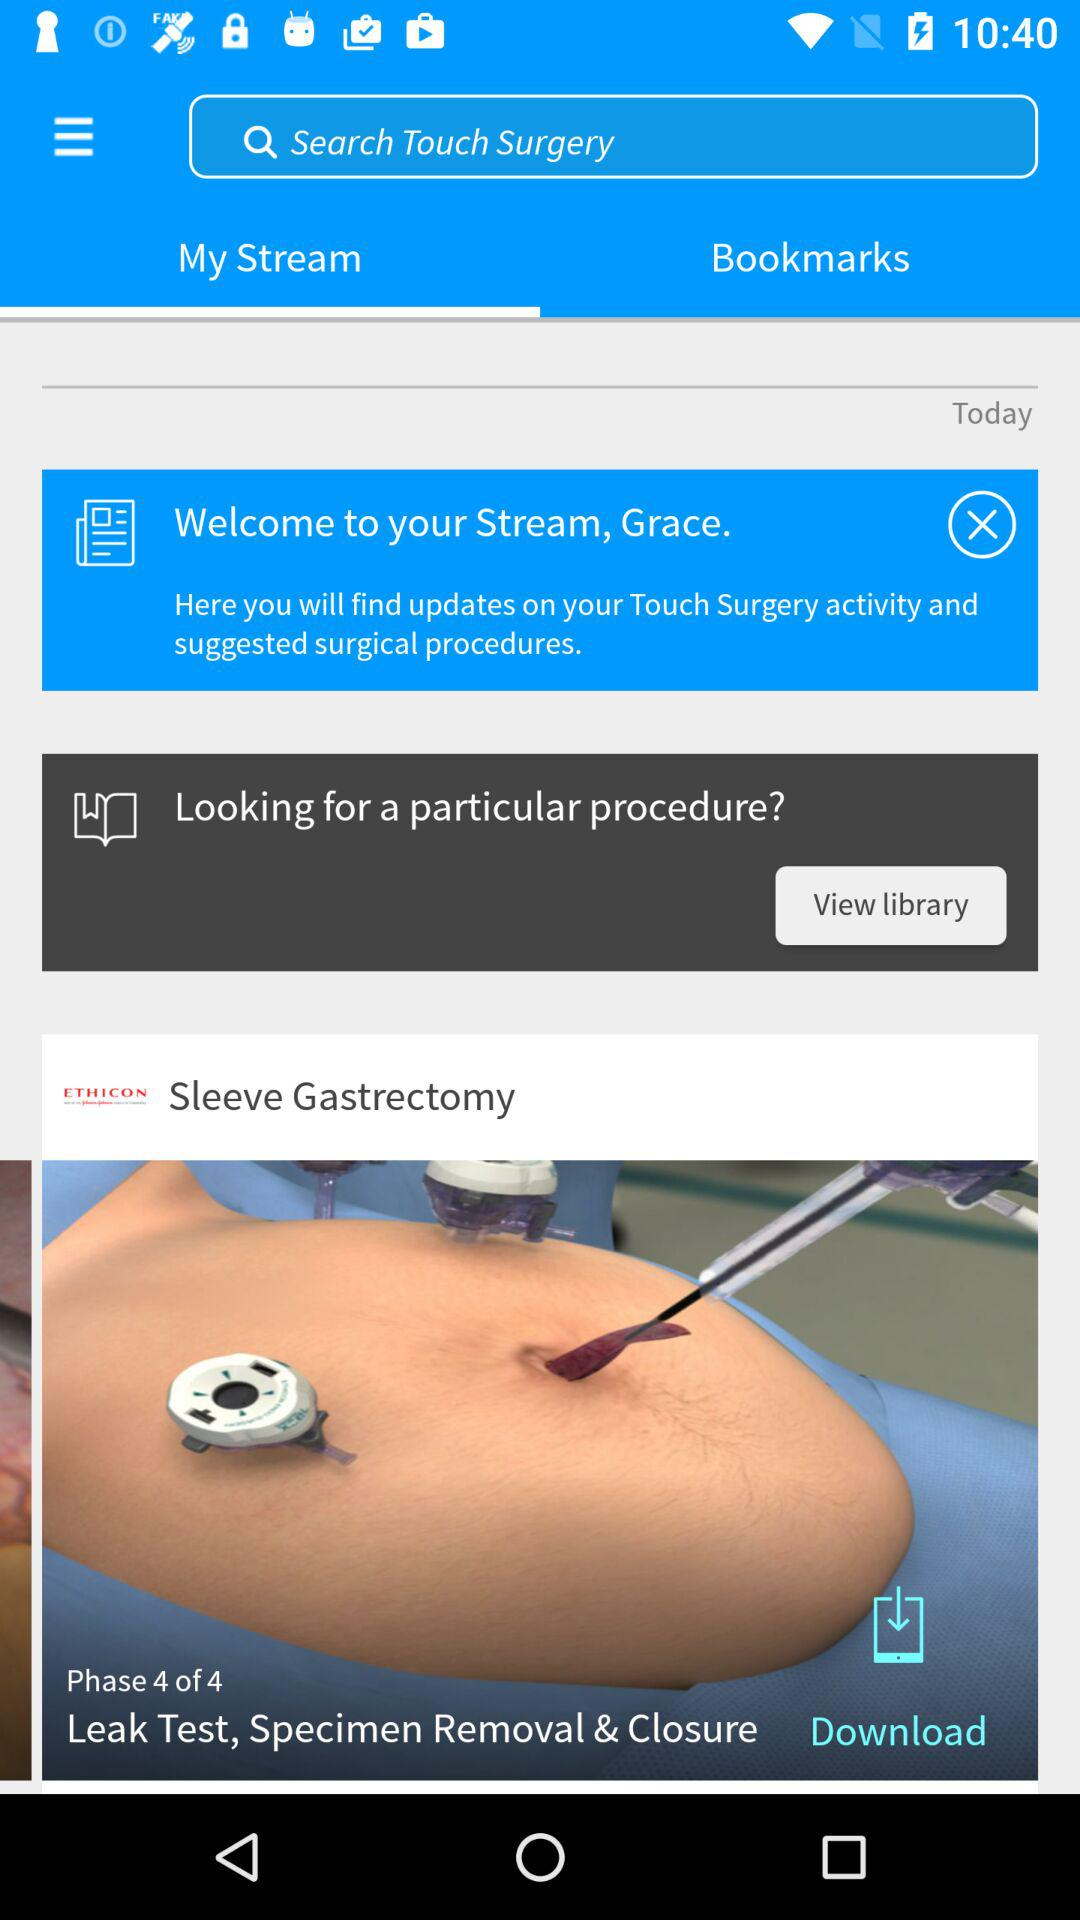What is phase 4 of the sleeve gastrectomy? Phase 4 of the sleeve gastrectomy is the leak test, specimen removal and closure. 